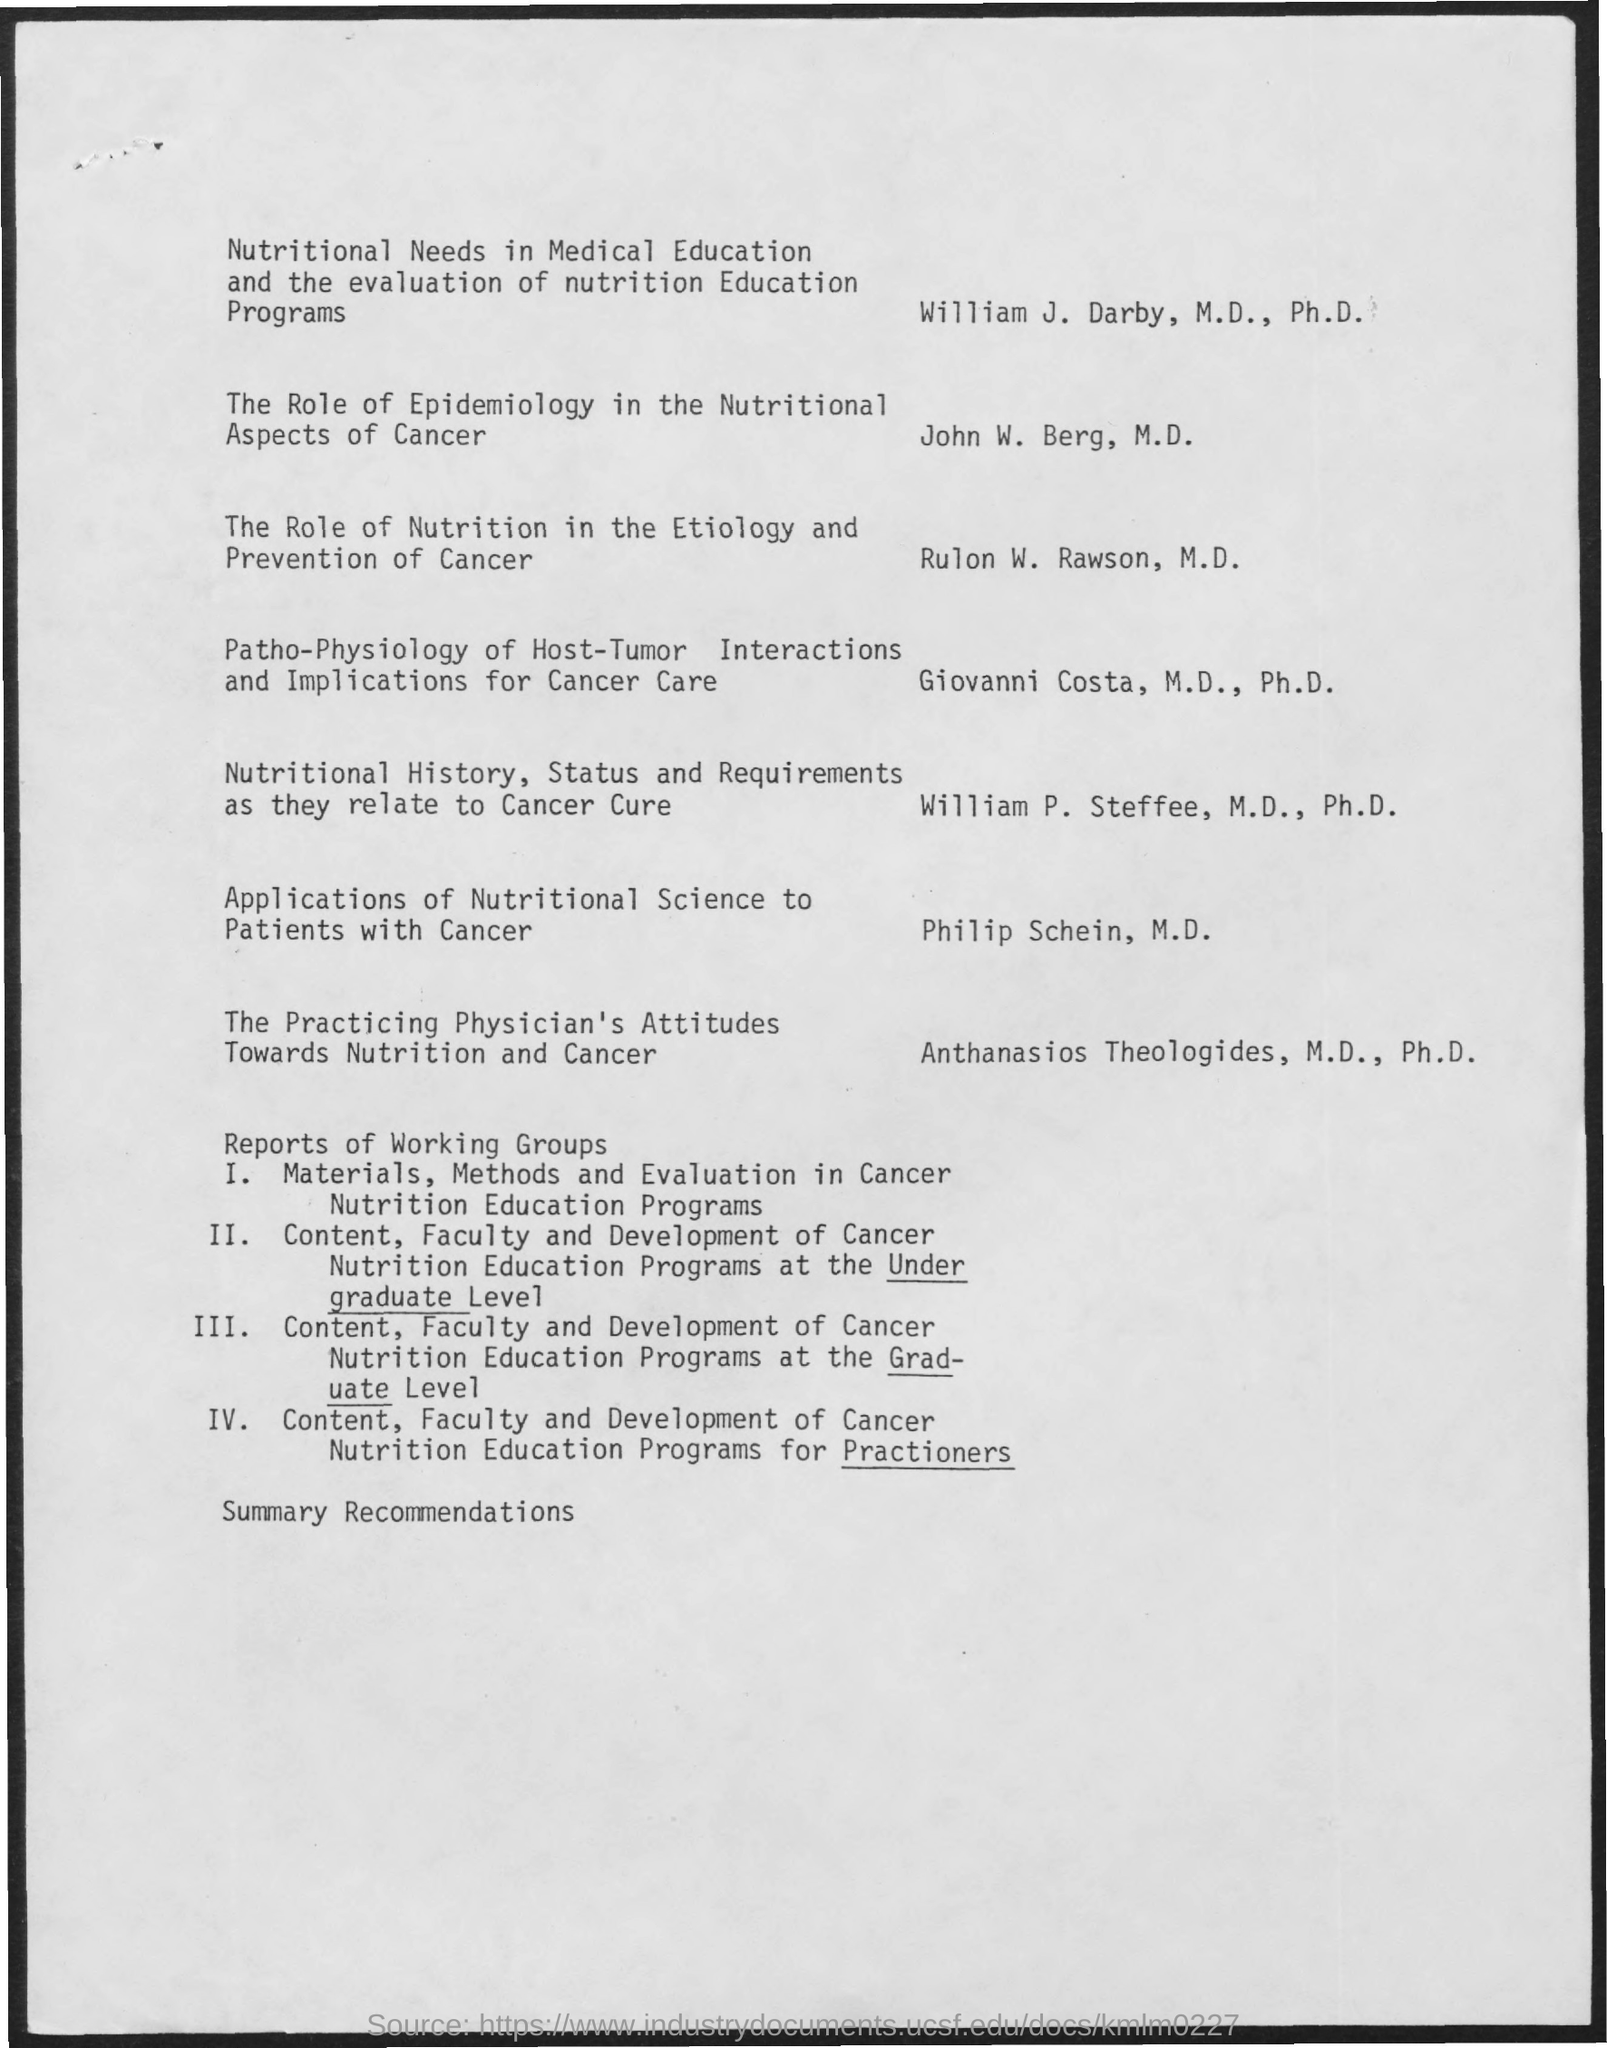Who did the "The Role of Epidemology in the Nutritional Aspects of Cancer"?
Give a very brief answer. John W. Berg, M.D. Who did the "The Role of Nutrition in theEtiology and Prevention of Cancer"?
Provide a succinct answer. Rulon W. Rawson, M.D. 